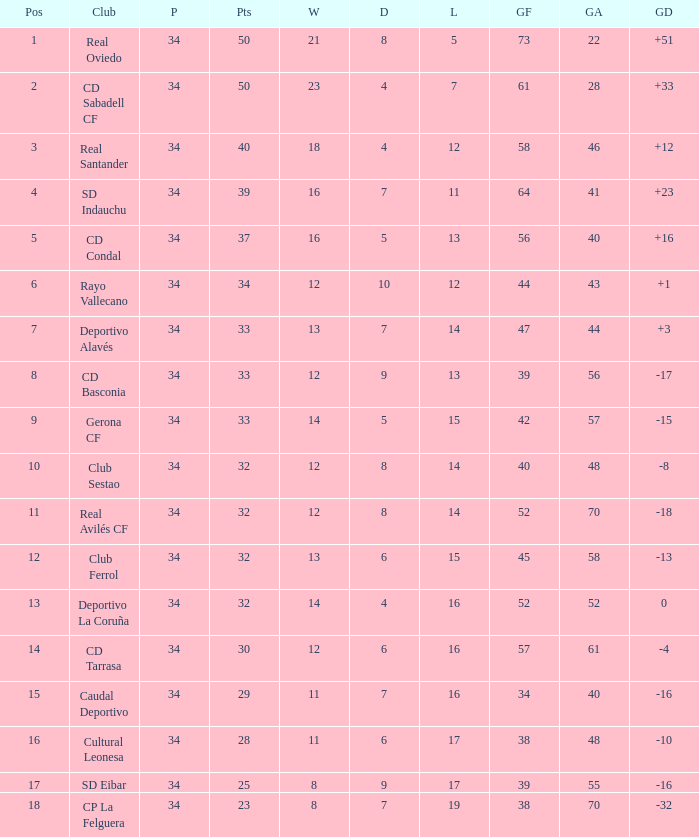Which Wins have a Goal Difference larger than 0, and Goals against larger than 40, and a Position smaller than 6, and a Club of sd indauchu? 16.0. 